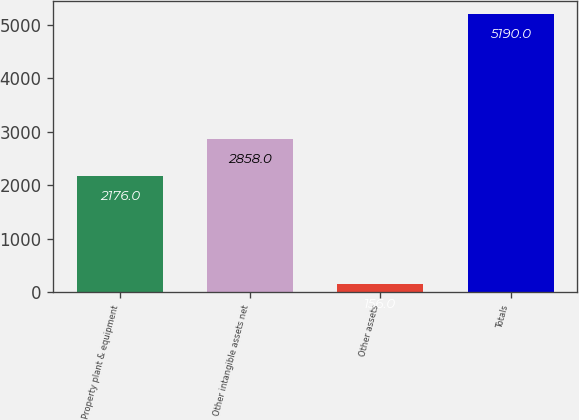Convert chart. <chart><loc_0><loc_0><loc_500><loc_500><bar_chart><fcel>Property plant & equipment<fcel>Other intangible assets net<fcel>Other assets<fcel>Totals<nl><fcel>2176<fcel>2858<fcel>156<fcel>5190<nl></chart> 